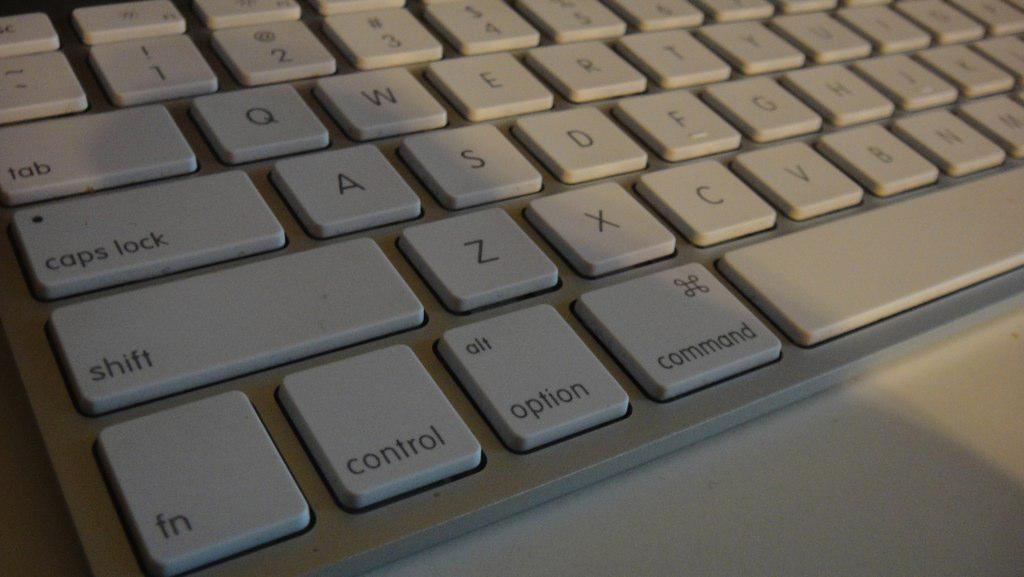Provide a one-sentence caption for the provided image. A white keyboard view on the left side of shift and control. 